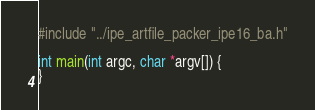Convert code to text. <code><loc_0><loc_0><loc_500><loc_500><_C_>#include "../ipe_artfile_packer_ipe16_ba.h"

int main(int argc, char *argv[]) {
}

</code> 